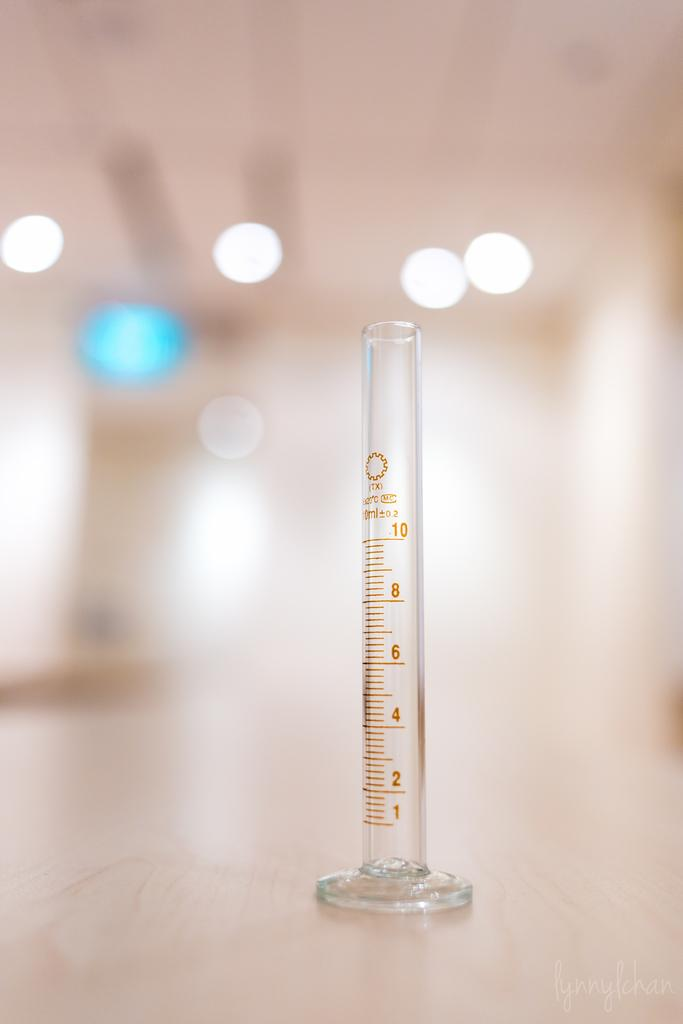<image>
Create a compact narrative representing the image presented. The number 10 is at the top of a glass tube. 